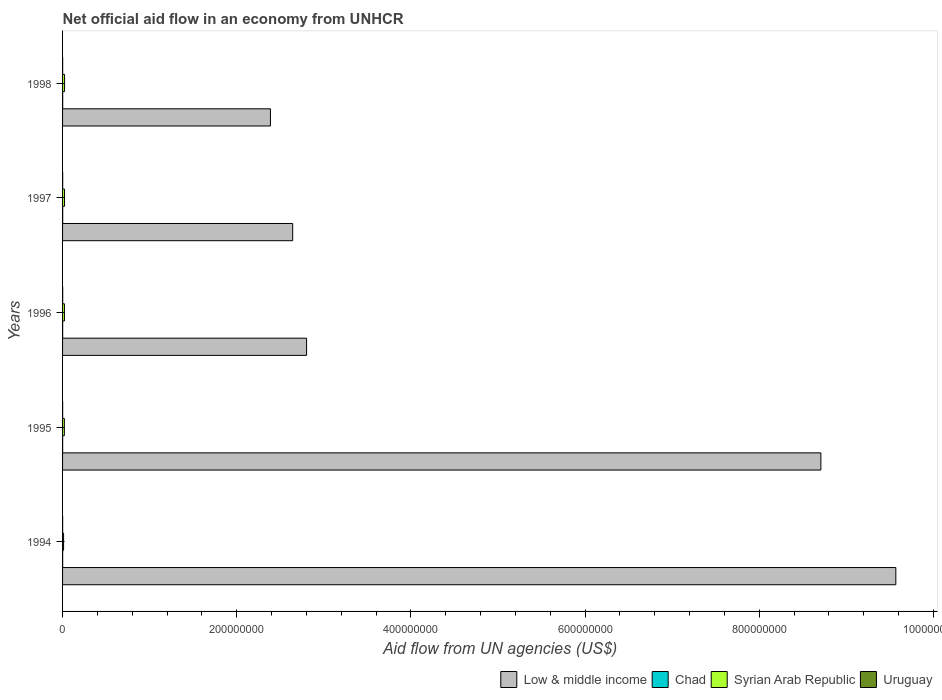Are the number of bars per tick equal to the number of legend labels?
Provide a succinct answer. Yes. Are the number of bars on each tick of the Y-axis equal?
Provide a short and direct response. Yes. How many bars are there on the 1st tick from the bottom?
Give a very brief answer. 4. What is the net official aid flow in Chad in 1997?
Your response must be concise. 1.40e+05. Across all years, what is the maximum net official aid flow in Syrian Arab Republic?
Make the answer very short. 2.30e+06. Across all years, what is the minimum net official aid flow in Chad?
Your response must be concise. 9.00e+04. In which year was the net official aid flow in Chad minimum?
Your response must be concise. 1995. What is the total net official aid flow in Syrian Arab Republic in the graph?
Offer a very short reply. 9.95e+06. What is the difference between the net official aid flow in Syrian Arab Republic in 1994 and that in 1996?
Your response must be concise. -1.01e+06. What is the difference between the net official aid flow in Uruguay in 1996 and the net official aid flow in Low & middle income in 1995?
Keep it short and to the point. -8.71e+08. What is the average net official aid flow in Low & middle income per year?
Provide a succinct answer. 5.22e+08. In the year 1994, what is the difference between the net official aid flow in Uruguay and net official aid flow in Syrian Arab Republic?
Provide a succinct answer. -1.07e+06. In how many years, is the net official aid flow in Low & middle income greater than 720000000 US$?
Provide a succinct answer. 2. Is the difference between the net official aid flow in Uruguay in 1994 and 1995 greater than the difference between the net official aid flow in Syrian Arab Republic in 1994 and 1995?
Ensure brevity in your answer.  Yes. What is the difference between the highest and the second highest net official aid flow in Uruguay?
Keep it short and to the point. 0. What is the difference between the highest and the lowest net official aid flow in Low & middle income?
Ensure brevity in your answer.  7.18e+08. In how many years, is the net official aid flow in Low & middle income greater than the average net official aid flow in Low & middle income taken over all years?
Your answer should be very brief. 2. Is the sum of the net official aid flow in Chad in 1995 and 1998 greater than the maximum net official aid flow in Syrian Arab Republic across all years?
Offer a very short reply. No. Is it the case that in every year, the sum of the net official aid flow in Syrian Arab Republic and net official aid flow in Chad is greater than the sum of net official aid flow in Uruguay and net official aid flow in Low & middle income?
Ensure brevity in your answer.  No. Is it the case that in every year, the sum of the net official aid flow in Chad and net official aid flow in Syrian Arab Republic is greater than the net official aid flow in Low & middle income?
Provide a succinct answer. No. How many bars are there?
Provide a short and direct response. 20. How many years are there in the graph?
Your answer should be very brief. 5. Are the values on the major ticks of X-axis written in scientific E-notation?
Keep it short and to the point. No. Does the graph contain any zero values?
Your answer should be very brief. No. Does the graph contain grids?
Offer a terse response. No. How many legend labels are there?
Provide a short and direct response. 4. How are the legend labels stacked?
Offer a terse response. Horizontal. What is the title of the graph?
Offer a terse response. Net official aid flow in an economy from UNHCR. Does "Mozambique" appear as one of the legend labels in the graph?
Keep it short and to the point. No. What is the label or title of the X-axis?
Provide a succinct answer. Aid flow from UN agencies (US$). What is the Aid flow from UN agencies (US$) of Low & middle income in 1994?
Ensure brevity in your answer.  9.57e+08. What is the Aid flow from UN agencies (US$) in Chad in 1994?
Your answer should be very brief. 1.10e+05. What is the Aid flow from UN agencies (US$) in Syrian Arab Republic in 1994?
Provide a short and direct response. 1.16e+06. What is the Aid flow from UN agencies (US$) of Uruguay in 1994?
Make the answer very short. 9.00e+04. What is the Aid flow from UN agencies (US$) of Low & middle income in 1995?
Make the answer very short. 8.71e+08. What is the Aid flow from UN agencies (US$) in Chad in 1995?
Provide a succinct answer. 9.00e+04. What is the Aid flow from UN agencies (US$) of Syrian Arab Republic in 1995?
Your response must be concise. 2.06e+06. What is the Aid flow from UN agencies (US$) of Low & middle income in 1996?
Your answer should be very brief. 2.80e+08. What is the Aid flow from UN agencies (US$) in Chad in 1996?
Your response must be concise. 1.10e+05. What is the Aid flow from UN agencies (US$) of Syrian Arab Republic in 1996?
Keep it short and to the point. 2.17e+06. What is the Aid flow from UN agencies (US$) in Uruguay in 1996?
Your answer should be compact. 1.20e+05. What is the Aid flow from UN agencies (US$) of Low & middle income in 1997?
Your answer should be compact. 2.64e+08. What is the Aid flow from UN agencies (US$) in Syrian Arab Republic in 1997?
Your answer should be very brief. 2.26e+06. What is the Aid flow from UN agencies (US$) of Uruguay in 1997?
Provide a short and direct response. 1.20e+05. What is the Aid flow from UN agencies (US$) of Low & middle income in 1998?
Offer a very short reply. 2.39e+08. What is the Aid flow from UN agencies (US$) in Chad in 1998?
Ensure brevity in your answer.  1.30e+05. What is the Aid flow from UN agencies (US$) of Syrian Arab Republic in 1998?
Your answer should be compact. 2.30e+06. Across all years, what is the maximum Aid flow from UN agencies (US$) of Low & middle income?
Your answer should be compact. 9.57e+08. Across all years, what is the maximum Aid flow from UN agencies (US$) in Syrian Arab Republic?
Your answer should be compact. 2.30e+06. Across all years, what is the minimum Aid flow from UN agencies (US$) of Low & middle income?
Your answer should be compact. 2.39e+08. Across all years, what is the minimum Aid flow from UN agencies (US$) in Chad?
Provide a short and direct response. 9.00e+04. Across all years, what is the minimum Aid flow from UN agencies (US$) of Syrian Arab Republic?
Your answer should be very brief. 1.16e+06. What is the total Aid flow from UN agencies (US$) in Low & middle income in the graph?
Keep it short and to the point. 2.61e+09. What is the total Aid flow from UN agencies (US$) in Chad in the graph?
Make the answer very short. 5.80e+05. What is the total Aid flow from UN agencies (US$) in Syrian Arab Republic in the graph?
Your response must be concise. 9.95e+06. What is the total Aid flow from UN agencies (US$) of Uruguay in the graph?
Ensure brevity in your answer.  5.40e+05. What is the difference between the Aid flow from UN agencies (US$) in Low & middle income in 1994 and that in 1995?
Provide a short and direct response. 8.61e+07. What is the difference between the Aid flow from UN agencies (US$) of Syrian Arab Republic in 1994 and that in 1995?
Keep it short and to the point. -9.00e+05. What is the difference between the Aid flow from UN agencies (US$) of Uruguay in 1994 and that in 1995?
Make the answer very short. -2.00e+04. What is the difference between the Aid flow from UN agencies (US$) in Low & middle income in 1994 and that in 1996?
Make the answer very short. 6.77e+08. What is the difference between the Aid flow from UN agencies (US$) in Syrian Arab Republic in 1994 and that in 1996?
Provide a short and direct response. -1.01e+06. What is the difference between the Aid flow from UN agencies (US$) of Low & middle income in 1994 and that in 1997?
Give a very brief answer. 6.93e+08. What is the difference between the Aid flow from UN agencies (US$) of Syrian Arab Republic in 1994 and that in 1997?
Your answer should be compact. -1.10e+06. What is the difference between the Aid flow from UN agencies (US$) of Uruguay in 1994 and that in 1997?
Offer a terse response. -3.00e+04. What is the difference between the Aid flow from UN agencies (US$) of Low & middle income in 1994 and that in 1998?
Your answer should be very brief. 7.18e+08. What is the difference between the Aid flow from UN agencies (US$) in Syrian Arab Republic in 1994 and that in 1998?
Offer a very short reply. -1.14e+06. What is the difference between the Aid flow from UN agencies (US$) of Low & middle income in 1995 and that in 1996?
Provide a short and direct response. 5.91e+08. What is the difference between the Aid flow from UN agencies (US$) in Chad in 1995 and that in 1996?
Provide a short and direct response. -2.00e+04. What is the difference between the Aid flow from UN agencies (US$) in Uruguay in 1995 and that in 1996?
Offer a terse response. -10000. What is the difference between the Aid flow from UN agencies (US$) in Low & middle income in 1995 and that in 1997?
Offer a terse response. 6.07e+08. What is the difference between the Aid flow from UN agencies (US$) of Chad in 1995 and that in 1997?
Your response must be concise. -5.00e+04. What is the difference between the Aid flow from UN agencies (US$) in Syrian Arab Republic in 1995 and that in 1997?
Offer a terse response. -2.00e+05. What is the difference between the Aid flow from UN agencies (US$) of Low & middle income in 1995 and that in 1998?
Ensure brevity in your answer.  6.32e+08. What is the difference between the Aid flow from UN agencies (US$) of Syrian Arab Republic in 1995 and that in 1998?
Offer a very short reply. -2.40e+05. What is the difference between the Aid flow from UN agencies (US$) of Uruguay in 1995 and that in 1998?
Your response must be concise. 10000. What is the difference between the Aid flow from UN agencies (US$) of Low & middle income in 1996 and that in 1997?
Keep it short and to the point. 1.59e+07. What is the difference between the Aid flow from UN agencies (US$) of Syrian Arab Republic in 1996 and that in 1997?
Make the answer very short. -9.00e+04. What is the difference between the Aid flow from UN agencies (US$) of Uruguay in 1996 and that in 1997?
Keep it short and to the point. 0. What is the difference between the Aid flow from UN agencies (US$) in Low & middle income in 1996 and that in 1998?
Make the answer very short. 4.15e+07. What is the difference between the Aid flow from UN agencies (US$) of Chad in 1996 and that in 1998?
Ensure brevity in your answer.  -2.00e+04. What is the difference between the Aid flow from UN agencies (US$) in Syrian Arab Republic in 1996 and that in 1998?
Your answer should be compact. -1.30e+05. What is the difference between the Aid flow from UN agencies (US$) of Low & middle income in 1997 and that in 1998?
Provide a short and direct response. 2.56e+07. What is the difference between the Aid flow from UN agencies (US$) of Low & middle income in 1994 and the Aid flow from UN agencies (US$) of Chad in 1995?
Offer a terse response. 9.57e+08. What is the difference between the Aid flow from UN agencies (US$) of Low & middle income in 1994 and the Aid flow from UN agencies (US$) of Syrian Arab Republic in 1995?
Keep it short and to the point. 9.55e+08. What is the difference between the Aid flow from UN agencies (US$) in Low & middle income in 1994 and the Aid flow from UN agencies (US$) in Uruguay in 1995?
Keep it short and to the point. 9.57e+08. What is the difference between the Aid flow from UN agencies (US$) of Chad in 1994 and the Aid flow from UN agencies (US$) of Syrian Arab Republic in 1995?
Your response must be concise. -1.95e+06. What is the difference between the Aid flow from UN agencies (US$) in Syrian Arab Republic in 1994 and the Aid flow from UN agencies (US$) in Uruguay in 1995?
Offer a terse response. 1.05e+06. What is the difference between the Aid flow from UN agencies (US$) in Low & middle income in 1994 and the Aid flow from UN agencies (US$) in Chad in 1996?
Your answer should be very brief. 9.57e+08. What is the difference between the Aid flow from UN agencies (US$) of Low & middle income in 1994 and the Aid flow from UN agencies (US$) of Syrian Arab Republic in 1996?
Keep it short and to the point. 9.55e+08. What is the difference between the Aid flow from UN agencies (US$) of Low & middle income in 1994 and the Aid flow from UN agencies (US$) of Uruguay in 1996?
Your response must be concise. 9.57e+08. What is the difference between the Aid flow from UN agencies (US$) of Chad in 1994 and the Aid flow from UN agencies (US$) of Syrian Arab Republic in 1996?
Provide a succinct answer. -2.06e+06. What is the difference between the Aid flow from UN agencies (US$) of Chad in 1994 and the Aid flow from UN agencies (US$) of Uruguay in 1996?
Make the answer very short. -10000. What is the difference between the Aid flow from UN agencies (US$) in Syrian Arab Republic in 1994 and the Aid flow from UN agencies (US$) in Uruguay in 1996?
Provide a succinct answer. 1.04e+06. What is the difference between the Aid flow from UN agencies (US$) in Low & middle income in 1994 and the Aid flow from UN agencies (US$) in Chad in 1997?
Offer a terse response. 9.57e+08. What is the difference between the Aid flow from UN agencies (US$) in Low & middle income in 1994 and the Aid flow from UN agencies (US$) in Syrian Arab Republic in 1997?
Make the answer very short. 9.55e+08. What is the difference between the Aid flow from UN agencies (US$) in Low & middle income in 1994 and the Aid flow from UN agencies (US$) in Uruguay in 1997?
Make the answer very short. 9.57e+08. What is the difference between the Aid flow from UN agencies (US$) in Chad in 1994 and the Aid flow from UN agencies (US$) in Syrian Arab Republic in 1997?
Ensure brevity in your answer.  -2.15e+06. What is the difference between the Aid flow from UN agencies (US$) of Syrian Arab Republic in 1994 and the Aid flow from UN agencies (US$) of Uruguay in 1997?
Make the answer very short. 1.04e+06. What is the difference between the Aid flow from UN agencies (US$) of Low & middle income in 1994 and the Aid flow from UN agencies (US$) of Chad in 1998?
Offer a very short reply. 9.57e+08. What is the difference between the Aid flow from UN agencies (US$) of Low & middle income in 1994 and the Aid flow from UN agencies (US$) of Syrian Arab Republic in 1998?
Give a very brief answer. 9.55e+08. What is the difference between the Aid flow from UN agencies (US$) in Low & middle income in 1994 and the Aid flow from UN agencies (US$) in Uruguay in 1998?
Your answer should be very brief. 9.57e+08. What is the difference between the Aid flow from UN agencies (US$) of Chad in 1994 and the Aid flow from UN agencies (US$) of Syrian Arab Republic in 1998?
Give a very brief answer. -2.19e+06. What is the difference between the Aid flow from UN agencies (US$) in Chad in 1994 and the Aid flow from UN agencies (US$) in Uruguay in 1998?
Ensure brevity in your answer.  10000. What is the difference between the Aid flow from UN agencies (US$) in Syrian Arab Republic in 1994 and the Aid flow from UN agencies (US$) in Uruguay in 1998?
Offer a terse response. 1.06e+06. What is the difference between the Aid flow from UN agencies (US$) in Low & middle income in 1995 and the Aid flow from UN agencies (US$) in Chad in 1996?
Your answer should be very brief. 8.71e+08. What is the difference between the Aid flow from UN agencies (US$) of Low & middle income in 1995 and the Aid flow from UN agencies (US$) of Syrian Arab Republic in 1996?
Offer a very short reply. 8.69e+08. What is the difference between the Aid flow from UN agencies (US$) of Low & middle income in 1995 and the Aid flow from UN agencies (US$) of Uruguay in 1996?
Your answer should be compact. 8.71e+08. What is the difference between the Aid flow from UN agencies (US$) in Chad in 1995 and the Aid flow from UN agencies (US$) in Syrian Arab Republic in 1996?
Your answer should be compact. -2.08e+06. What is the difference between the Aid flow from UN agencies (US$) of Chad in 1995 and the Aid flow from UN agencies (US$) of Uruguay in 1996?
Make the answer very short. -3.00e+04. What is the difference between the Aid flow from UN agencies (US$) in Syrian Arab Republic in 1995 and the Aid flow from UN agencies (US$) in Uruguay in 1996?
Offer a very short reply. 1.94e+06. What is the difference between the Aid flow from UN agencies (US$) of Low & middle income in 1995 and the Aid flow from UN agencies (US$) of Chad in 1997?
Provide a short and direct response. 8.71e+08. What is the difference between the Aid flow from UN agencies (US$) of Low & middle income in 1995 and the Aid flow from UN agencies (US$) of Syrian Arab Republic in 1997?
Offer a terse response. 8.69e+08. What is the difference between the Aid flow from UN agencies (US$) of Low & middle income in 1995 and the Aid flow from UN agencies (US$) of Uruguay in 1997?
Your answer should be very brief. 8.71e+08. What is the difference between the Aid flow from UN agencies (US$) in Chad in 1995 and the Aid flow from UN agencies (US$) in Syrian Arab Republic in 1997?
Offer a very short reply. -2.17e+06. What is the difference between the Aid flow from UN agencies (US$) in Syrian Arab Republic in 1995 and the Aid flow from UN agencies (US$) in Uruguay in 1997?
Make the answer very short. 1.94e+06. What is the difference between the Aid flow from UN agencies (US$) of Low & middle income in 1995 and the Aid flow from UN agencies (US$) of Chad in 1998?
Your answer should be very brief. 8.71e+08. What is the difference between the Aid flow from UN agencies (US$) in Low & middle income in 1995 and the Aid flow from UN agencies (US$) in Syrian Arab Republic in 1998?
Ensure brevity in your answer.  8.69e+08. What is the difference between the Aid flow from UN agencies (US$) of Low & middle income in 1995 and the Aid flow from UN agencies (US$) of Uruguay in 1998?
Your answer should be compact. 8.71e+08. What is the difference between the Aid flow from UN agencies (US$) of Chad in 1995 and the Aid flow from UN agencies (US$) of Syrian Arab Republic in 1998?
Your response must be concise. -2.21e+06. What is the difference between the Aid flow from UN agencies (US$) of Chad in 1995 and the Aid flow from UN agencies (US$) of Uruguay in 1998?
Provide a succinct answer. -10000. What is the difference between the Aid flow from UN agencies (US$) in Syrian Arab Republic in 1995 and the Aid flow from UN agencies (US$) in Uruguay in 1998?
Ensure brevity in your answer.  1.96e+06. What is the difference between the Aid flow from UN agencies (US$) in Low & middle income in 1996 and the Aid flow from UN agencies (US$) in Chad in 1997?
Give a very brief answer. 2.80e+08. What is the difference between the Aid flow from UN agencies (US$) of Low & middle income in 1996 and the Aid flow from UN agencies (US$) of Syrian Arab Republic in 1997?
Give a very brief answer. 2.78e+08. What is the difference between the Aid flow from UN agencies (US$) of Low & middle income in 1996 and the Aid flow from UN agencies (US$) of Uruguay in 1997?
Make the answer very short. 2.80e+08. What is the difference between the Aid flow from UN agencies (US$) in Chad in 1996 and the Aid flow from UN agencies (US$) in Syrian Arab Republic in 1997?
Keep it short and to the point. -2.15e+06. What is the difference between the Aid flow from UN agencies (US$) of Chad in 1996 and the Aid flow from UN agencies (US$) of Uruguay in 1997?
Provide a short and direct response. -10000. What is the difference between the Aid flow from UN agencies (US$) in Syrian Arab Republic in 1996 and the Aid flow from UN agencies (US$) in Uruguay in 1997?
Offer a terse response. 2.05e+06. What is the difference between the Aid flow from UN agencies (US$) in Low & middle income in 1996 and the Aid flow from UN agencies (US$) in Chad in 1998?
Keep it short and to the point. 2.80e+08. What is the difference between the Aid flow from UN agencies (US$) of Low & middle income in 1996 and the Aid flow from UN agencies (US$) of Syrian Arab Republic in 1998?
Provide a short and direct response. 2.78e+08. What is the difference between the Aid flow from UN agencies (US$) in Low & middle income in 1996 and the Aid flow from UN agencies (US$) in Uruguay in 1998?
Offer a very short reply. 2.80e+08. What is the difference between the Aid flow from UN agencies (US$) of Chad in 1996 and the Aid flow from UN agencies (US$) of Syrian Arab Republic in 1998?
Your answer should be compact. -2.19e+06. What is the difference between the Aid flow from UN agencies (US$) in Chad in 1996 and the Aid flow from UN agencies (US$) in Uruguay in 1998?
Ensure brevity in your answer.  10000. What is the difference between the Aid flow from UN agencies (US$) in Syrian Arab Republic in 1996 and the Aid flow from UN agencies (US$) in Uruguay in 1998?
Give a very brief answer. 2.07e+06. What is the difference between the Aid flow from UN agencies (US$) of Low & middle income in 1997 and the Aid flow from UN agencies (US$) of Chad in 1998?
Your answer should be compact. 2.64e+08. What is the difference between the Aid flow from UN agencies (US$) of Low & middle income in 1997 and the Aid flow from UN agencies (US$) of Syrian Arab Republic in 1998?
Keep it short and to the point. 2.62e+08. What is the difference between the Aid flow from UN agencies (US$) in Low & middle income in 1997 and the Aid flow from UN agencies (US$) in Uruguay in 1998?
Your response must be concise. 2.64e+08. What is the difference between the Aid flow from UN agencies (US$) of Chad in 1997 and the Aid flow from UN agencies (US$) of Syrian Arab Republic in 1998?
Keep it short and to the point. -2.16e+06. What is the difference between the Aid flow from UN agencies (US$) in Chad in 1997 and the Aid flow from UN agencies (US$) in Uruguay in 1998?
Provide a short and direct response. 4.00e+04. What is the difference between the Aid flow from UN agencies (US$) in Syrian Arab Republic in 1997 and the Aid flow from UN agencies (US$) in Uruguay in 1998?
Make the answer very short. 2.16e+06. What is the average Aid flow from UN agencies (US$) of Low & middle income per year?
Your answer should be compact. 5.22e+08. What is the average Aid flow from UN agencies (US$) in Chad per year?
Provide a short and direct response. 1.16e+05. What is the average Aid flow from UN agencies (US$) in Syrian Arab Republic per year?
Offer a very short reply. 1.99e+06. What is the average Aid flow from UN agencies (US$) of Uruguay per year?
Make the answer very short. 1.08e+05. In the year 1994, what is the difference between the Aid flow from UN agencies (US$) of Low & middle income and Aid flow from UN agencies (US$) of Chad?
Ensure brevity in your answer.  9.57e+08. In the year 1994, what is the difference between the Aid flow from UN agencies (US$) of Low & middle income and Aid flow from UN agencies (US$) of Syrian Arab Republic?
Your response must be concise. 9.56e+08. In the year 1994, what is the difference between the Aid flow from UN agencies (US$) in Low & middle income and Aid flow from UN agencies (US$) in Uruguay?
Give a very brief answer. 9.57e+08. In the year 1994, what is the difference between the Aid flow from UN agencies (US$) of Chad and Aid flow from UN agencies (US$) of Syrian Arab Republic?
Make the answer very short. -1.05e+06. In the year 1994, what is the difference between the Aid flow from UN agencies (US$) of Syrian Arab Republic and Aid flow from UN agencies (US$) of Uruguay?
Offer a terse response. 1.07e+06. In the year 1995, what is the difference between the Aid flow from UN agencies (US$) of Low & middle income and Aid flow from UN agencies (US$) of Chad?
Give a very brief answer. 8.71e+08. In the year 1995, what is the difference between the Aid flow from UN agencies (US$) of Low & middle income and Aid flow from UN agencies (US$) of Syrian Arab Republic?
Offer a very short reply. 8.69e+08. In the year 1995, what is the difference between the Aid flow from UN agencies (US$) in Low & middle income and Aid flow from UN agencies (US$) in Uruguay?
Your response must be concise. 8.71e+08. In the year 1995, what is the difference between the Aid flow from UN agencies (US$) in Chad and Aid flow from UN agencies (US$) in Syrian Arab Republic?
Provide a short and direct response. -1.97e+06. In the year 1995, what is the difference between the Aid flow from UN agencies (US$) of Syrian Arab Republic and Aid flow from UN agencies (US$) of Uruguay?
Provide a short and direct response. 1.95e+06. In the year 1996, what is the difference between the Aid flow from UN agencies (US$) of Low & middle income and Aid flow from UN agencies (US$) of Chad?
Keep it short and to the point. 2.80e+08. In the year 1996, what is the difference between the Aid flow from UN agencies (US$) of Low & middle income and Aid flow from UN agencies (US$) of Syrian Arab Republic?
Your answer should be compact. 2.78e+08. In the year 1996, what is the difference between the Aid flow from UN agencies (US$) of Low & middle income and Aid flow from UN agencies (US$) of Uruguay?
Your answer should be very brief. 2.80e+08. In the year 1996, what is the difference between the Aid flow from UN agencies (US$) of Chad and Aid flow from UN agencies (US$) of Syrian Arab Republic?
Give a very brief answer. -2.06e+06. In the year 1996, what is the difference between the Aid flow from UN agencies (US$) in Chad and Aid flow from UN agencies (US$) in Uruguay?
Offer a terse response. -10000. In the year 1996, what is the difference between the Aid flow from UN agencies (US$) of Syrian Arab Republic and Aid flow from UN agencies (US$) of Uruguay?
Make the answer very short. 2.05e+06. In the year 1997, what is the difference between the Aid flow from UN agencies (US$) of Low & middle income and Aid flow from UN agencies (US$) of Chad?
Offer a very short reply. 2.64e+08. In the year 1997, what is the difference between the Aid flow from UN agencies (US$) in Low & middle income and Aid flow from UN agencies (US$) in Syrian Arab Republic?
Ensure brevity in your answer.  2.62e+08. In the year 1997, what is the difference between the Aid flow from UN agencies (US$) in Low & middle income and Aid flow from UN agencies (US$) in Uruguay?
Make the answer very short. 2.64e+08. In the year 1997, what is the difference between the Aid flow from UN agencies (US$) of Chad and Aid flow from UN agencies (US$) of Syrian Arab Republic?
Your response must be concise. -2.12e+06. In the year 1997, what is the difference between the Aid flow from UN agencies (US$) of Syrian Arab Republic and Aid flow from UN agencies (US$) of Uruguay?
Your answer should be very brief. 2.14e+06. In the year 1998, what is the difference between the Aid flow from UN agencies (US$) in Low & middle income and Aid flow from UN agencies (US$) in Chad?
Offer a very short reply. 2.39e+08. In the year 1998, what is the difference between the Aid flow from UN agencies (US$) in Low & middle income and Aid flow from UN agencies (US$) in Syrian Arab Republic?
Provide a short and direct response. 2.36e+08. In the year 1998, what is the difference between the Aid flow from UN agencies (US$) of Low & middle income and Aid flow from UN agencies (US$) of Uruguay?
Provide a succinct answer. 2.39e+08. In the year 1998, what is the difference between the Aid flow from UN agencies (US$) of Chad and Aid flow from UN agencies (US$) of Syrian Arab Republic?
Provide a short and direct response. -2.17e+06. In the year 1998, what is the difference between the Aid flow from UN agencies (US$) in Syrian Arab Republic and Aid flow from UN agencies (US$) in Uruguay?
Provide a short and direct response. 2.20e+06. What is the ratio of the Aid flow from UN agencies (US$) in Low & middle income in 1994 to that in 1995?
Ensure brevity in your answer.  1.1. What is the ratio of the Aid flow from UN agencies (US$) in Chad in 1994 to that in 1995?
Provide a succinct answer. 1.22. What is the ratio of the Aid flow from UN agencies (US$) of Syrian Arab Republic in 1994 to that in 1995?
Offer a very short reply. 0.56. What is the ratio of the Aid flow from UN agencies (US$) in Uruguay in 1994 to that in 1995?
Give a very brief answer. 0.82. What is the ratio of the Aid flow from UN agencies (US$) of Low & middle income in 1994 to that in 1996?
Keep it short and to the point. 3.41. What is the ratio of the Aid flow from UN agencies (US$) in Syrian Arab Republic in 1994 to that in 1996?
Ensure brevity in your answer.  0.53. What is the ratio of the Aid flow from UN agencies (US$) of Uruguay in 1994 to that in 1996?
Keep it short and to the point. 0.75. What is the ratio of the Aid flow from UN agencies (US$) in Low & middle income in 1994 to that in 1997?
Provide a succinct answer. 3.62. What is the ratio of the Aid flow from UN agencies (US$) of Chad in 1994 to that in 1997?
Keep it short and to the point. 0.79. What is the ratio of the Aid flow from UN agencies (US$) in Syrian Arab Republic in 1994 to that in 1997?
Your answer should be compact. 0.51. What is the ratio of the Aid flow from UN agencies (US$) in Low & middle income in 1994 to that in 1998?
Give a very brief answer. 4.01. What is the ratio of the Aid flow from UN agencies (US$) in Chad in 1994 to that in 1998?
Your answer should be very brief. 0.85. What is the ratio of the Aid flow from UN agencies (US$) in Syrian Arab Republic in 1994 to that in 1998?
Keep it short and to the point. 0.5. What is the ratio of the Aid flow from UN agencies (US$) of Uruguay in 1994 to that in 1998?
Provide a short and direct response. 0.9. What is the ratio of the Aid flow from UN agencies (US$) in Low & middle income in 1995 to that in 1996?
Provide a succinct answer. 3.11. What is the ratio of the Aid flow from UN agencies (US$) in Chad in 1995 to that in 1996?
Your response must be concise. 0.82. What is the ratio of the Aid flow from UN agencies (US$) in Syrian Arab Republic in 1995 to that in 1996?
Provide a short and direct response. 0.95. What is the ratio of the Aid flow from UN agencies (US$) of Uruguay in 1995 to that in 1996?
Provide a short and direct response. 0.92. What is the ratio of the Aid flow from UN agencies (US$) of Low & middle income in 1995 to that in 1997?
Your answer should be very brief. 3.3. What is the ratio of the Aid flow from UN agencies (US$) in Chad in 1995 to that in 1997?
Give a very brief answer. 0.64. What is the ratio of the Aid flow from UN agencies (US$) in Syrian Arab Republic in 1995 to that in 1997?
Your response must be concise. 0.91. What is the ratio of the Aid flow from UN agencies (US$) of Uruguay in 1995 to that in 1997?
Offer a very short reply. 0.92. What is the ratio of the Aid flow from UN agencies (US$) of Low & middle income in 1995 to that in 1998?
Make the answer very short. 3.65. What is the ratio of the Aid flow from UN agencies (US$) in Chad in 1995 to that in 1998?
Keep it short and to the point. 0.69. What is the ratio of the Aid flow from UN agencies (US$) in Syrian Arab Republic in 1995 to that in 1998?
Ensure brevity in your answer.  0.9. What is the ratio of the Aid flow from UN agencies (US$) in Uruguay in 1995 to that in 1998?
Give a very brief answer. 1.1. What is the ratio of the Aid flow from UN agencies (US$) of Low & middle income in 1996 to that in 1997?
Provide a succinct answer. 1.06. What is the ratio of the Aid flow from UN agencies (US$) in Chad in 1996 to that in 1997?
Give a very brief answer. 0.79. What is the ratio of the Aid flow from UN agencies (US$) in Syrian Arab Republic in 1996 to that in 1997?
Make the answer very short. 0.96. What is the ratio of the Aid flow from UN agencies (US$) in Low & middle income in 1996 to that in 1998?
Your answer should be very brief. 1.17. What is the ratio of the Aid flow from UN agencies (US$) of Chad in 1996 to that in 1998?
Your response must be concise. 0.85. What is the ratio of the Aid flow from UN agencies (US$) in Syrian Arab Republic in 1996 to that in 1998?
Offer a very short reply. 0.94. What is the ratio of the Aid flow from UN agencies (US$) of Uruguay in 1996 to that in 1998?
Ensure brevity in your answer.  1.2. What is the ratio of the Aid flow from UN agencies (US$) of Low & middle income in 1997 to that in 1998?
Offer a terse response. 1.11. What is the ratio of the Aid flow from UN agencies (US$) of Syrian Arab Republic in 1997 to that in 1998?
Provide a succinct answer. 0.98. What is the ratio of the Aid flow from UN agencies (US$) in Uruguay in 1997 to that in 1998?
Your answer should be compact. 1.2. What is the difference between the highest and the second highest Aid flow from UN agencies (US$) of Low & middle income?
Your answer should be compact. 8.61e+07. What is the difference between the highest and the second highest Aid flow from UN agencies (US$) of Chad?
Offer a terse response. 10000. What is the difference between the highest and the second highest Aid flow from UN agencies (US$) of Uruguay?
Provide a short and direct response. 0. What is the difference between the highest and the lowest Aid flow from UN agencies (US$) of Low & middle income?
Your answer should be compact. 7.18e+08. What is the difference between the highest and the lowest Aid flow from UN agencies (US$) in Syrian Arab Republic?
Ensure brevity in your answer.  1.14e+06. 